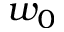Convert formula to latex. <formula><loc_0><loc_0><loc_500><loc_500>w _ { 0 }</formula> 